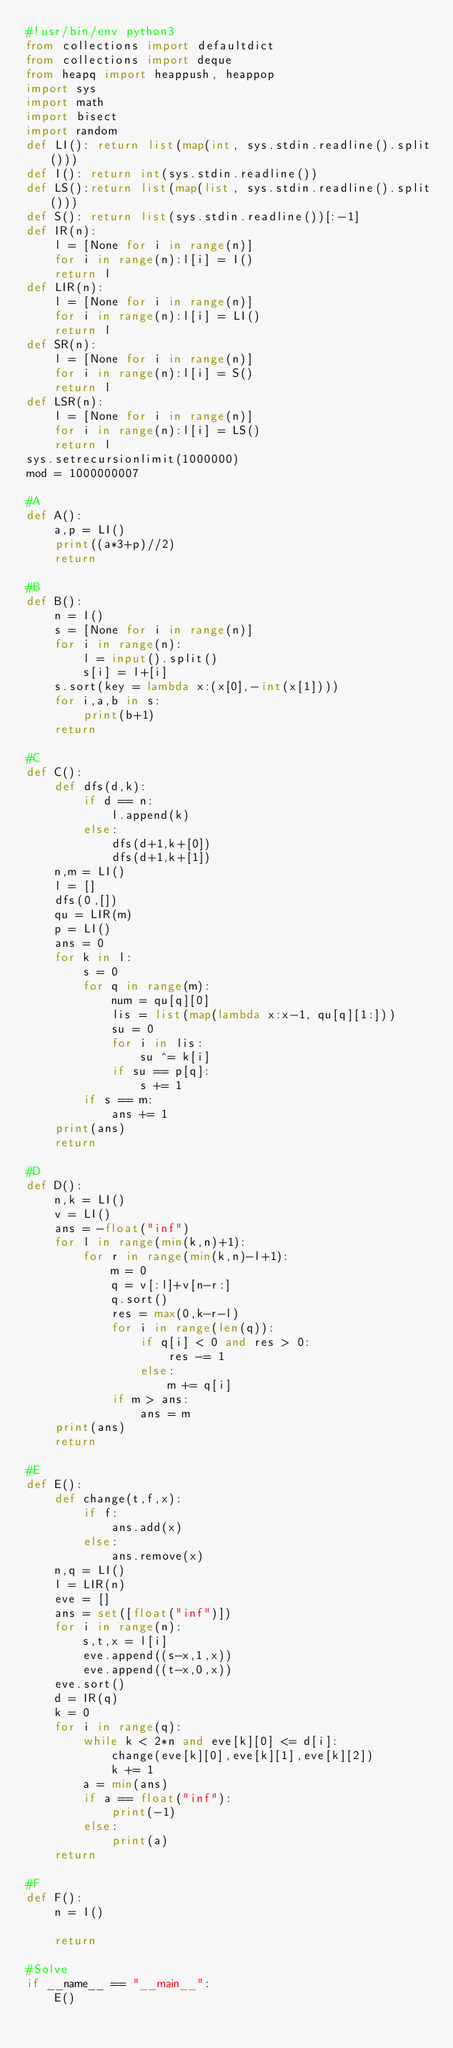<code> <loc_0><loc_0><loc_500><loc_500><_Python_>#!usr/bin/env python3
from collections import defaultdict
from collections import deque
from heapq import heappush, heappop
import sys
import math
import bisect
import random
def LI(): return list(map(int, sys.stdin.readline().split()))
def I(): return int(sys.stdin.readline())
def LS():return list(map(list, sys.stdin.readline().split()))
def S(): return list(sys.stdin.readline())[:-1]
def IR(n):
    l = [None for i in range(n)]
    for i in range(n):l[i] = I()
    return l
def LIR(n):
    l = [None for i in range(n)]
    for i in range(n):l[i] = LI()
    return l
def SR(n):
    l = [None for i in range(n)]
    for i in range(n):l[i] = S()
    return l
def LSR(n):
    l = [None for i in range(n)]
    for i in range(n):l[i] = LS()
    return l
sys.setrecursionlimit(1000000)
mod = 1000000007

#A
def A():
    a,p = LI()
    print((a*3+p)//2)
    return

#B
def B():
    n = I()
    s = [None for i in range(n)]
    for i in range(n):
        l = input().split()
        s[i] = l+[i]
    s.sort(key = lambda x:(x[0],-int(x[1])))
    for i,a,b in s:
        print(b+1)
    return

#C
def C():
    def dfs(d,k):
        if d == n:
            l.append(k)
        else:
            dfs(d+1,k+[0])
            dfs(d+1,k+[1])
    n,m = LI()
    l = []
    dfs(0,[])
    qu = LIR(m)
    p = LI()
    ans = 0
    for k in l:
        s = 0
        for q in range(m):
            num = qu[q][0]
            lis = list(map(lambda x:x-1, qu[q][1:]))
            su = 0
            for i in lis:
                su ^= k[i]
            if su == p[q]:
                s += 1
        if s == m:
            ans += 1
    print(ans)
    return

#D
def D():
    n,k = LI()
    v = LI()
    ans = -float("inf")
    for l in range(min(k,n)+1):
        for r in range(min(k,n)-l+1):
            m = 0
            q = v[:l]+v[n-r:]
            q.sort()
            res = max(0,k-r-l)
            for i in range(len(q)):
                if q[i] < 0 and res > 0:
                    res -= 1
                else:
                    m += q[i]
            if m > ans:
                ans = m
    print(ans)
    return

#E
def E():
    def change(t,f,x):
        if f:
            ans.add(x)
        else:
            ans.remove(x)
    n,q = LI()
    l = LIR(n)
    eve = []
    ans = set([float("inf")])
    for i in range(n):
        s,t,x = l[i]
        eve.append((s-x,1,x))
        eve.append((t-x,0,x))
    eve.sort()
    d = IR(q)
    k = 0
    for i in range(q):
        while k < 2*n and eve[k][0] <= d[i]:
            change(eve[k][0],eve[k][1],eve[k][2])
            k += 1
        a = min(ans)
        if a == float("inf"):
            print(-1)
        else:
            print(a)
    return

#F
def F():
    n = I()

    return

#Solve
if __name__ == "__main__":
    E()
</code> 